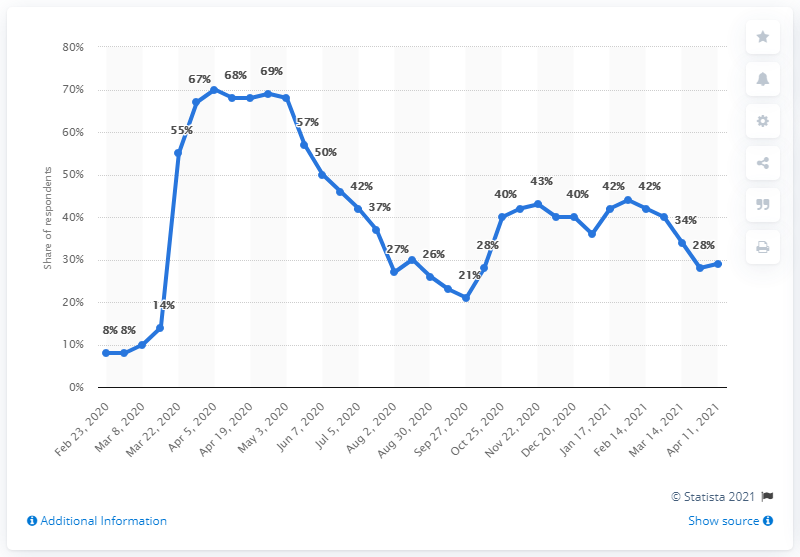Outline some significant characteristics in this image. A significant proportion of Malaysian respondents, almost a third, stated that they had been avoiding going to work during the COVID-19 outbreak. 